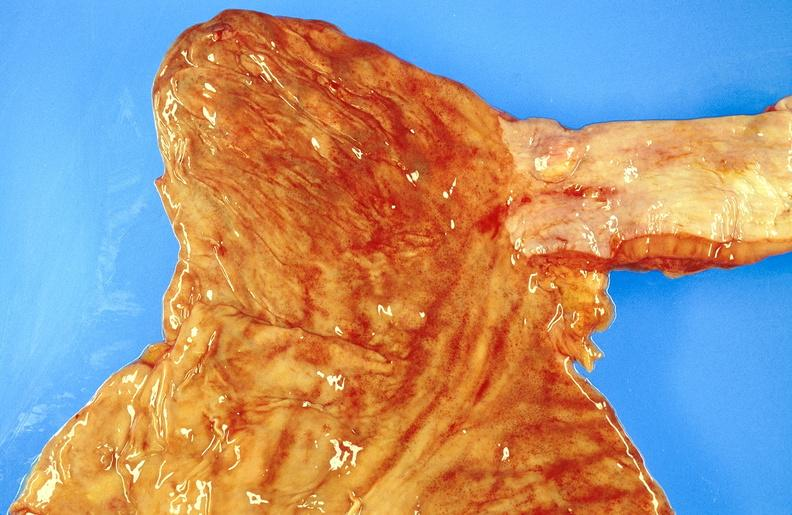where does this belong to?
Answer the question using a single word or phrase. Gastrointestinal system 